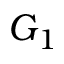Convert formula to latex. <formula><loc_0><loc_0><loc_500><loc_500>G _ { 1 }</formula> 